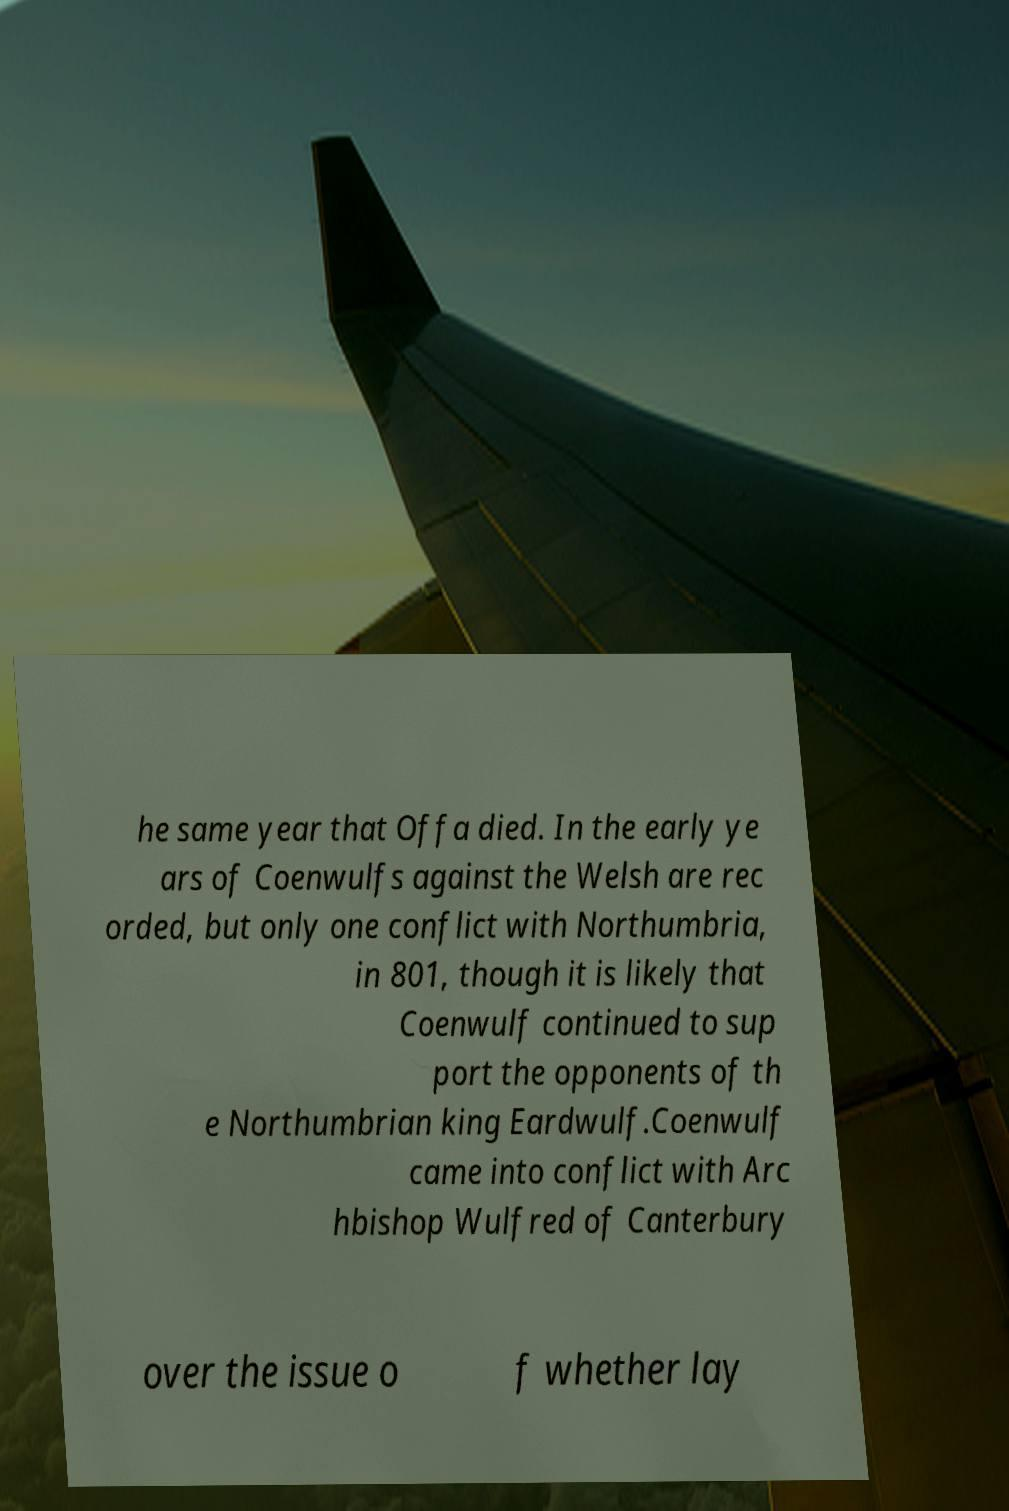Could you assist in decoding the text presented in this image and type it out clearly? he same year that Offa died. In the early ye ars of Coenwulfs against the Welsh are rec orded, but only one conflict with Northumbria, in 801, though it is likely that Coenwulf continued to sup port the opponents of th e Northumbrian king Eardwulf.Coenwulf came into conflict with Arc hbishop Wulfred of Canterbury over the issue o f whether lay 